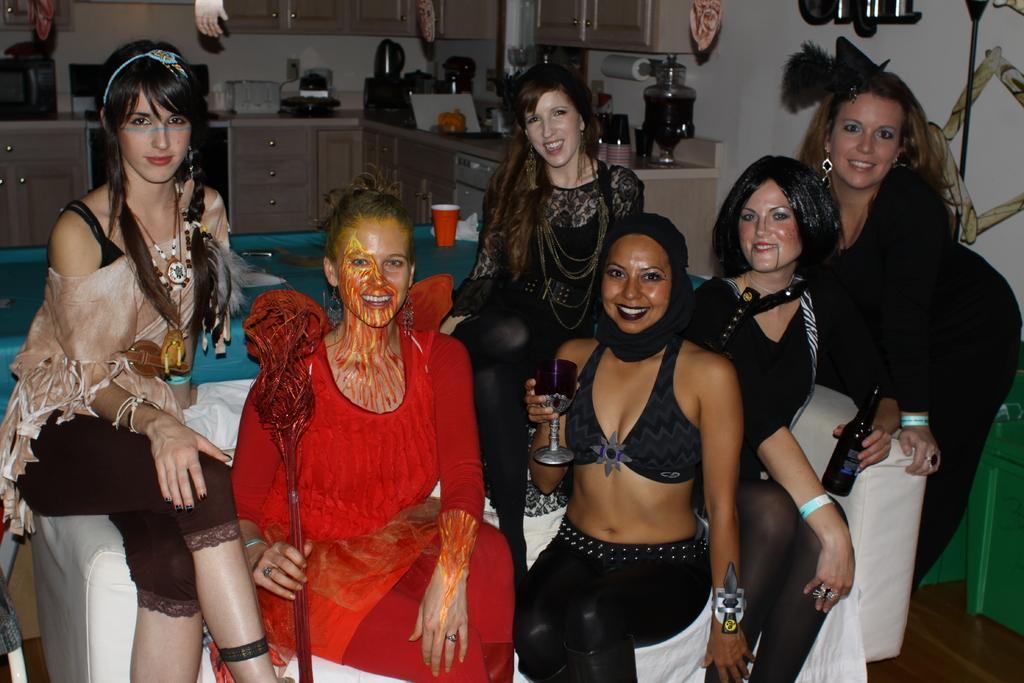Can you describe this image briefly? A group of girls are sitting on the sofa, this girl holding a wine glass in her hand. 